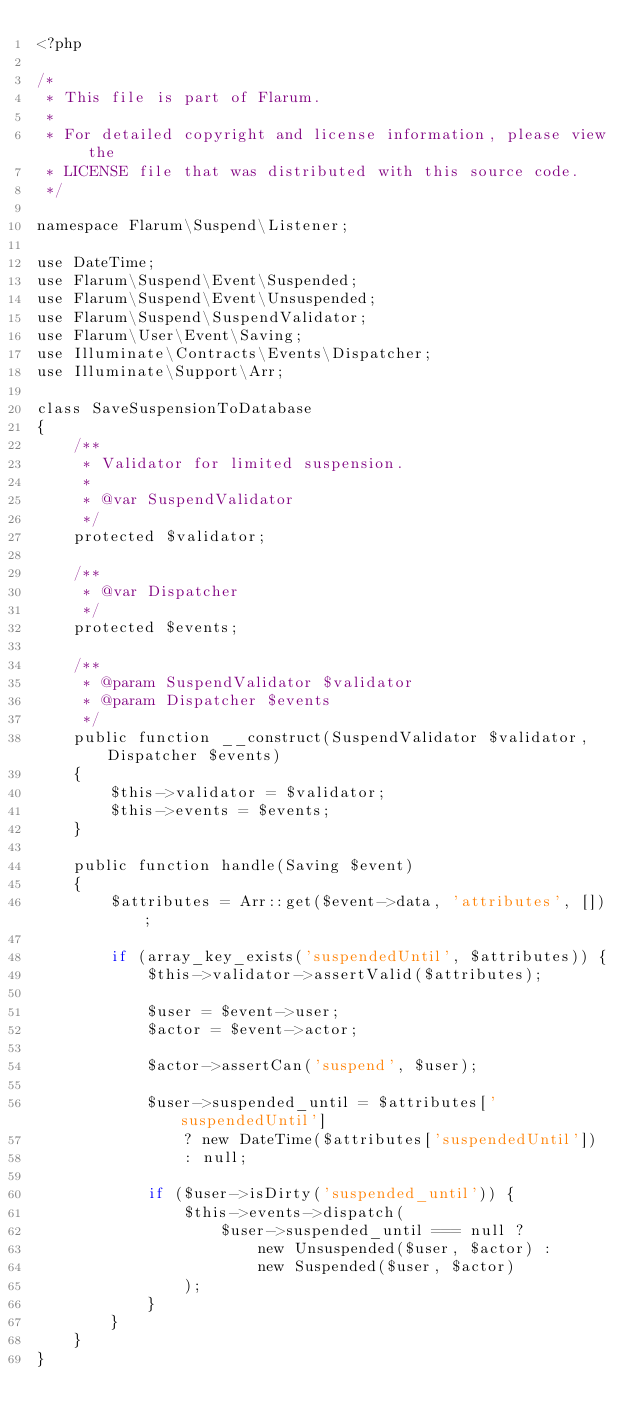Convert code to text. <code><loc_0><loc_0><loc_500><loc_500><_PHP_><?php

/*
 * This file is part of Flarum.
 *
 * For detailed copyright and license information, please view the
 * LICENSE file that was distributed with this source code.
 */

namespace Flarum\Suspend\Listener;

use DateTime;
use Flarum\Suspend\Event\Suspended;
use Flarum\Suspend\Event\Unsuspended;
use Flarum\Suspend\SuspendValidator;
use Flarum\User\Event\Saving;
use Illuminate\Contracts\Events\Dispatcher;
use Illuminate\Support\Arr;

class SaveSuspensionToDatabase
{
    /**
     * Validator for limited suspension.
     *
     * @var SuspendValidator
     */
    protected $validator;

    /**
     * @var Dispatcher
     */
    protected $events;

    /**
     * @param SuspendValidator $validator
     * @param Dispatcher $events
     */
    public function __construct(SuspendValidator $validator, Dispatcher $events)
    {
        $this->validator = $validator;
        $this->events = $events;
    }

    public function handle(Saving $event)
    {
        $attributes = Arr::get($event->data, 'attributes', []);

        if (array_key_exists('suspendedUntil', $attributes)) {
            $this->validator->assertValid($attributes);

            $user = $event->user;
            $actor = $event->actor;

            $actor->assertCan('suspend', $user);

            $user->suspended_until = $attributes['suspendedUntil']
                ? new DateTime($attributes['suspendedUntil'])
                : null;

            if ($user->isDirty('suspended_until')) {
                $this->events->dispatch(
                    $user->suspended_until === null ?
                        new Unsuspended($user, $actor) :
                        new Suspended($user, $actor)
                );
            }
        }
    }
}
</code> 